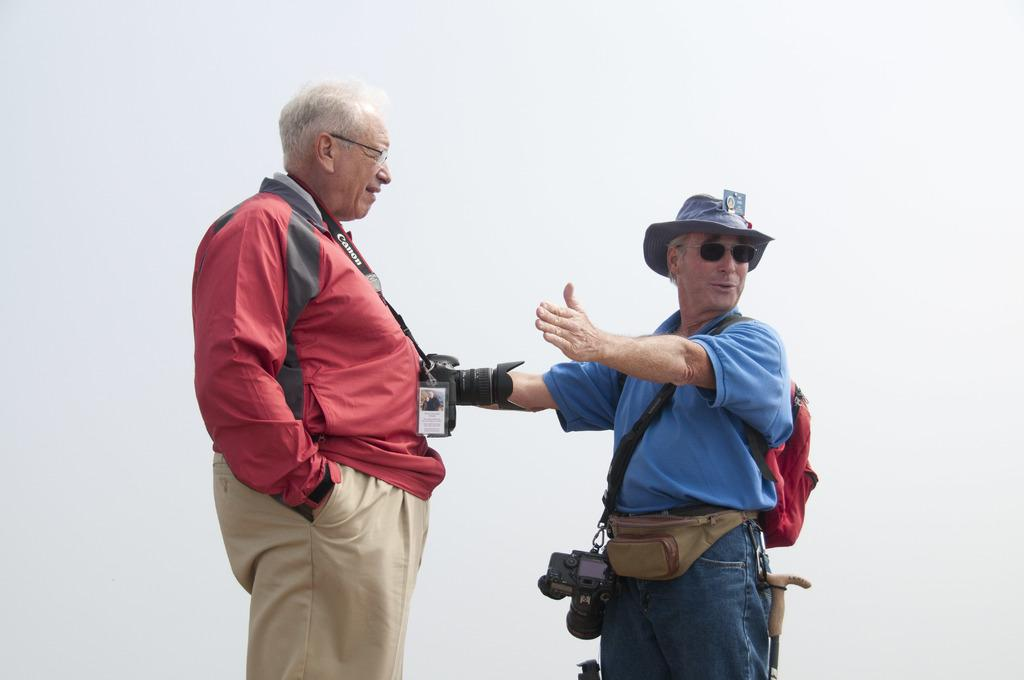How many people are in the image? There are two men in the image. What are the men wearing? Both men are wearing cameras. Can you describe the attire of one of the men? One man is wearing a bag, hat, and a walking stick. What is visible in the background of the image? The sky is visible in the image. How would you describe the weather based on the sky? The sky appears cloudy, which might suggest overcast or potentially rainy weather. What type of income do the men in the image have? There is no information about the men's income in the image, so it cannot be determined. 